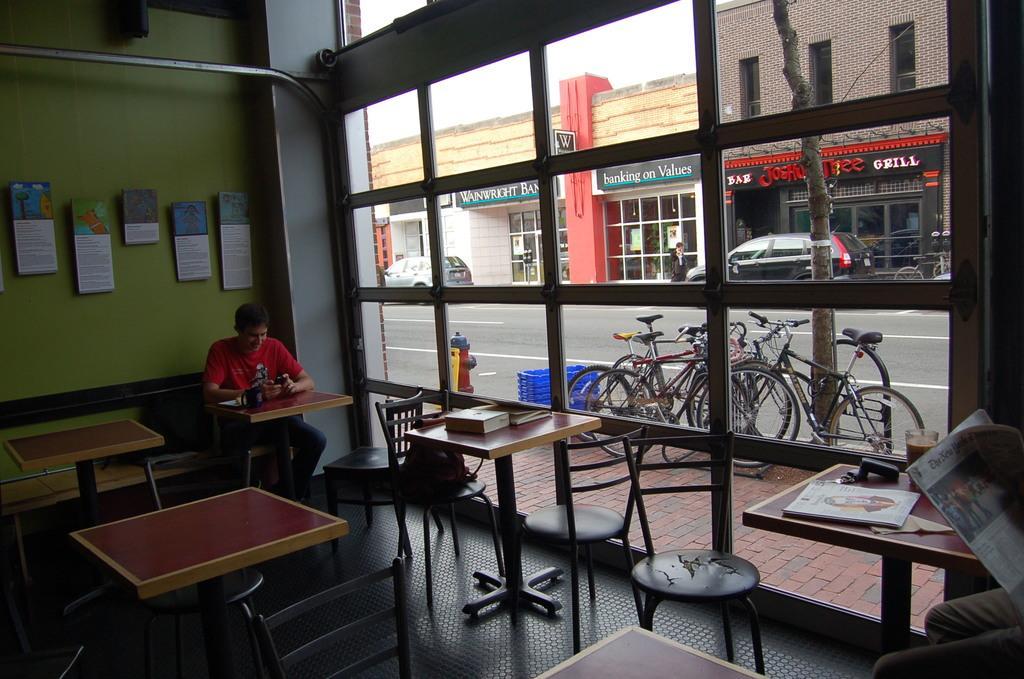In one or two sentences, can you explain what this image depicts? The person wearing red shirt is sitting in front of a table and operating a mobile phone and there are some tables and chairs in front of him and there is another person reading news paper in the right corner and there are group of cycles,stores,cars beside him. 